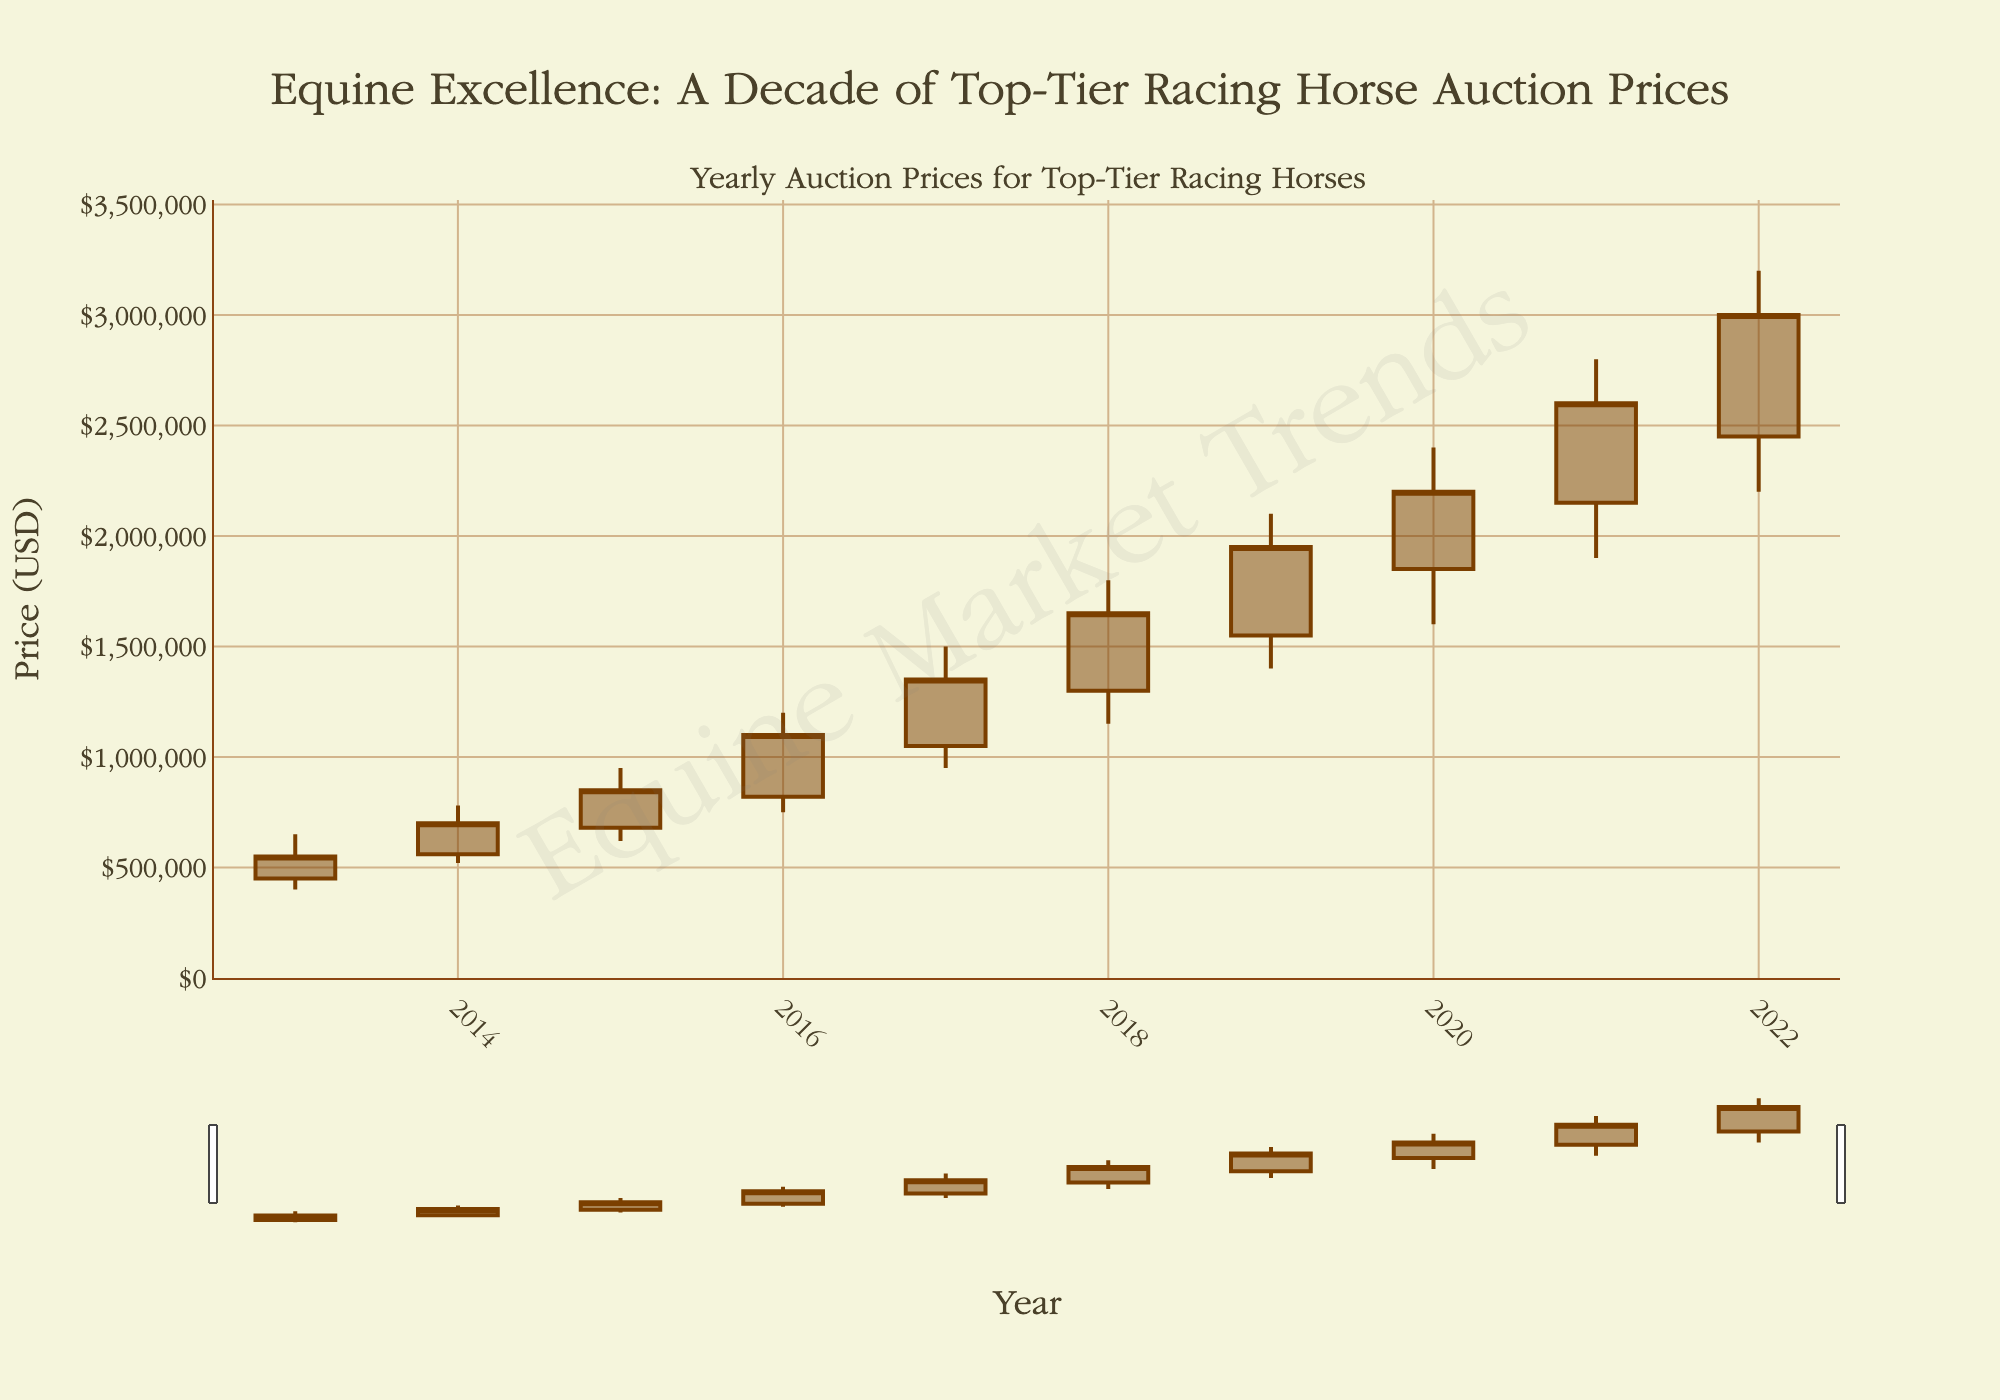what is the title of the figure? The title of the figure is usually displayed at the top and often summarizes the content of the chart. In this case, it’s clearly written.
Answer: Equine Excellence: A Decade of Top-Tier Racing Horse Auction Prices How much did the highest price in 2017 compare to that in 2013? Look at the high price for 2017 and 2013 from the vertical bars on the chart. The difference is obtained by subtracting 2013's high from 2017's high.
Answer: $850,000 What was the low price for the year 2021? Locate the year 2021 on the x-axis, then find the lowest point of the bar representing the lowest price for that year.
Answer: $1,900,000 what was the trend in closing prices over the decade? Check the closing prices for each year and observe the pattern. The closing prices consistently increase each year.
Answer: Increasing How does the range of prices in 2020 compare to 2018? The price range is the difference between the high and low prices. Calculate this for both years to compare.
Answer: 2020 had a higher range In which year was the difference between the opening and closing prices the largest? For each year, calculate the absolute difference between the opening and closing prices, then identify the year with the largest difference.
Answer: 2019 What was the average high price over the decade? Sum the high prices for all the years and divide by the number of years (10) to get the average.
Answer: $1,802,000 Which year had the highest opening price? Examine the bars representing the opening prices and identify the highest one.
Answer: 2022 When did the closing prices surpass two million dollars? Check the closing prices for each year and look for the first instance where they exceed two million dollars.
Answer: 2020 Did any year have decreasing prices (close price less than the open price)? Compare the open and close prices for each year to see if the close price was ever less than the open price.
Answer: No 